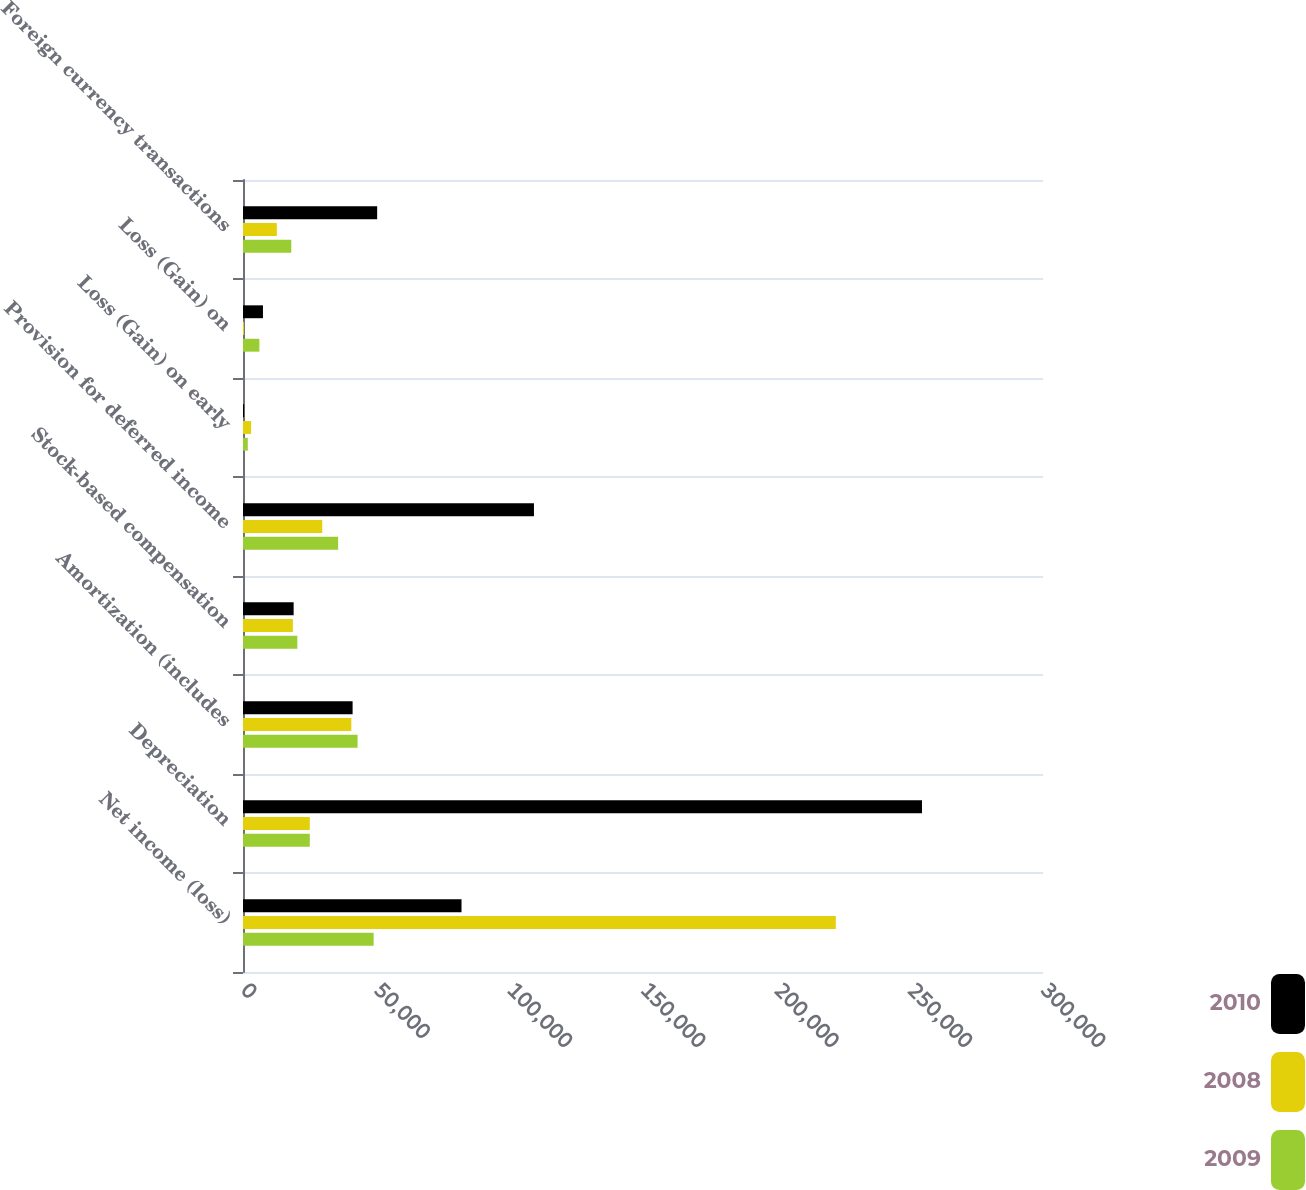Convert chart to OTSL. <chart><loc_0><loc_0><loc_500><loc_500><stacked_bar_chart><ecel><fcel>Net income (loss)<fcel>Depreciation<fcel>Amortization (includes<fcel>Stock-based compensation<fcel>Provision for deferred income<fcel>Loss (Gain) on early<fcel>Loss (Gain) on<fcel>Foreign currency transactions<nl><fcel>2010<fcel>81943<fcel>254619<fcel>41101<fcel>18988<fcel>109109<fcel>418<fcel>7483<fcel>50312<nl><fcel>2008<fcel>222306<fcel>25050.5<fcel>40618<fcel>18703<fcel>29723<fcel>3031<fcel>406<fcel>12686<nl><fcel>2009<fcel>48992<fcel>25050.5<fcel>42970<fcel>20378<fcel>35674<fcel>1792<fcel>6143<fcel>18105<nl></chart> 